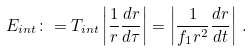<formula> <loc_0><loc_0><loc_500><loc_500>E _ { i n t } \colon = T _ { i n t } \left | \frac { 1 } { r } \frac { d r } { d \tau } \right | = \left | \frac { 1 } { f _ { 1 } r ^ { 2 } } \frac { d r } { d t } \right | \, .</formula> 